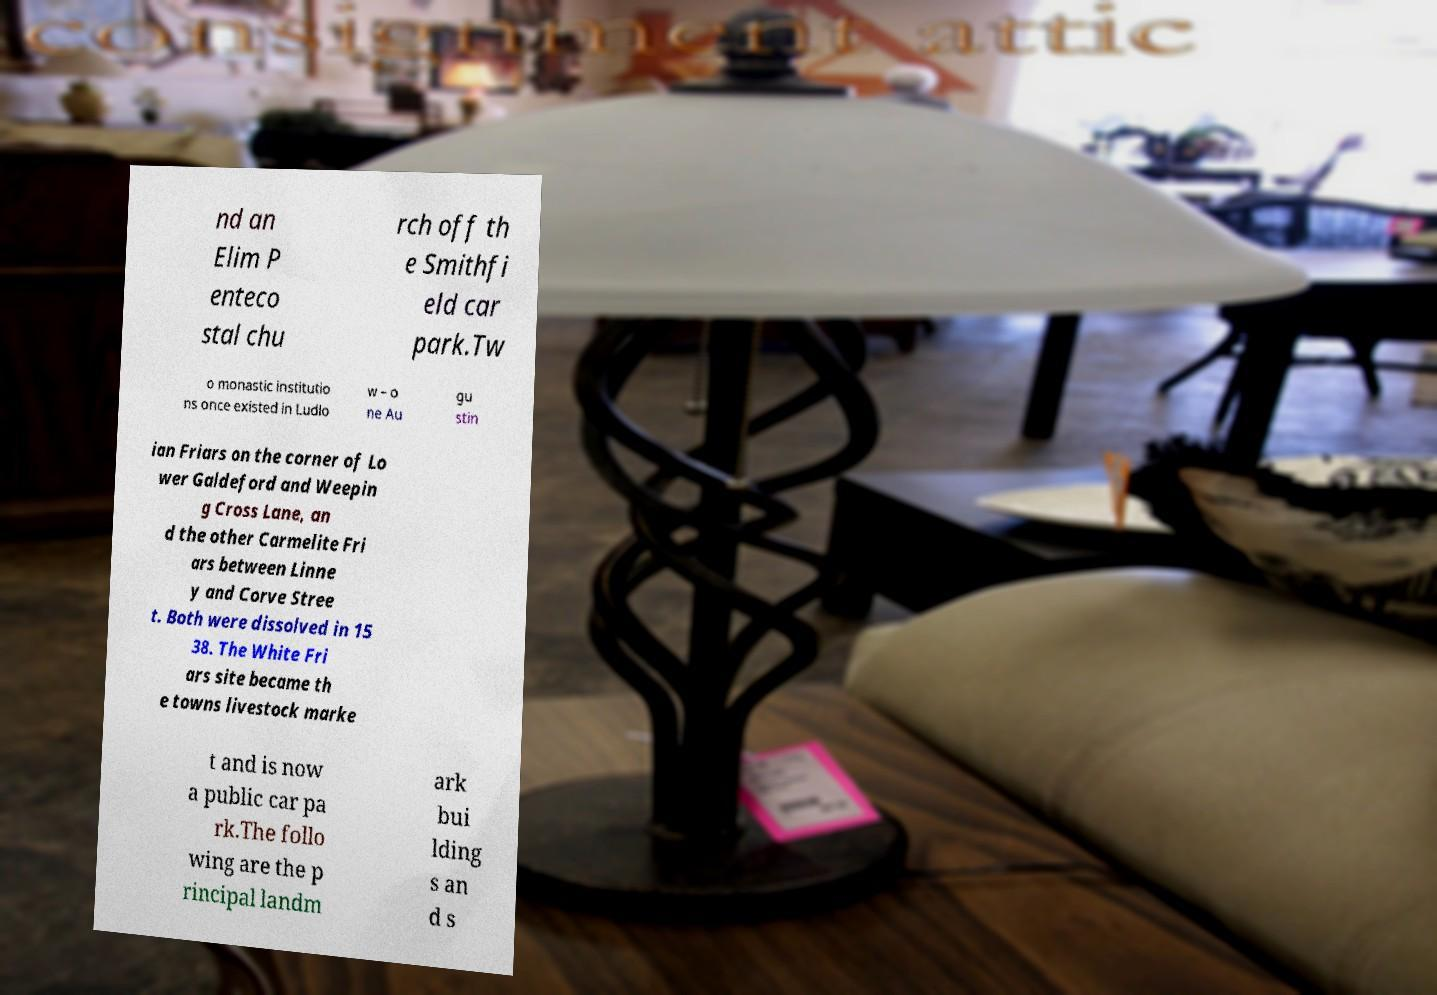Can you accurately transcribe the text from the provided image for me? nd an Elim P enteco stal chu rch off th e Smithfi eld car park.Tw o monastic institutio ns once existed in Ludlo w – o ne Au gu stin ian Friars on the corner of Lo wer Galdeford and Weepin g Cross Lane, an d the other Carmelite Fri ars between Linne y and Corve Stree t. Both were dissolved in 15 38. The White Fri ars site became th e towns livestock marke t and is now a public car pa rk.The follo wing are the p rincipal landm ark bui lding s an d s 